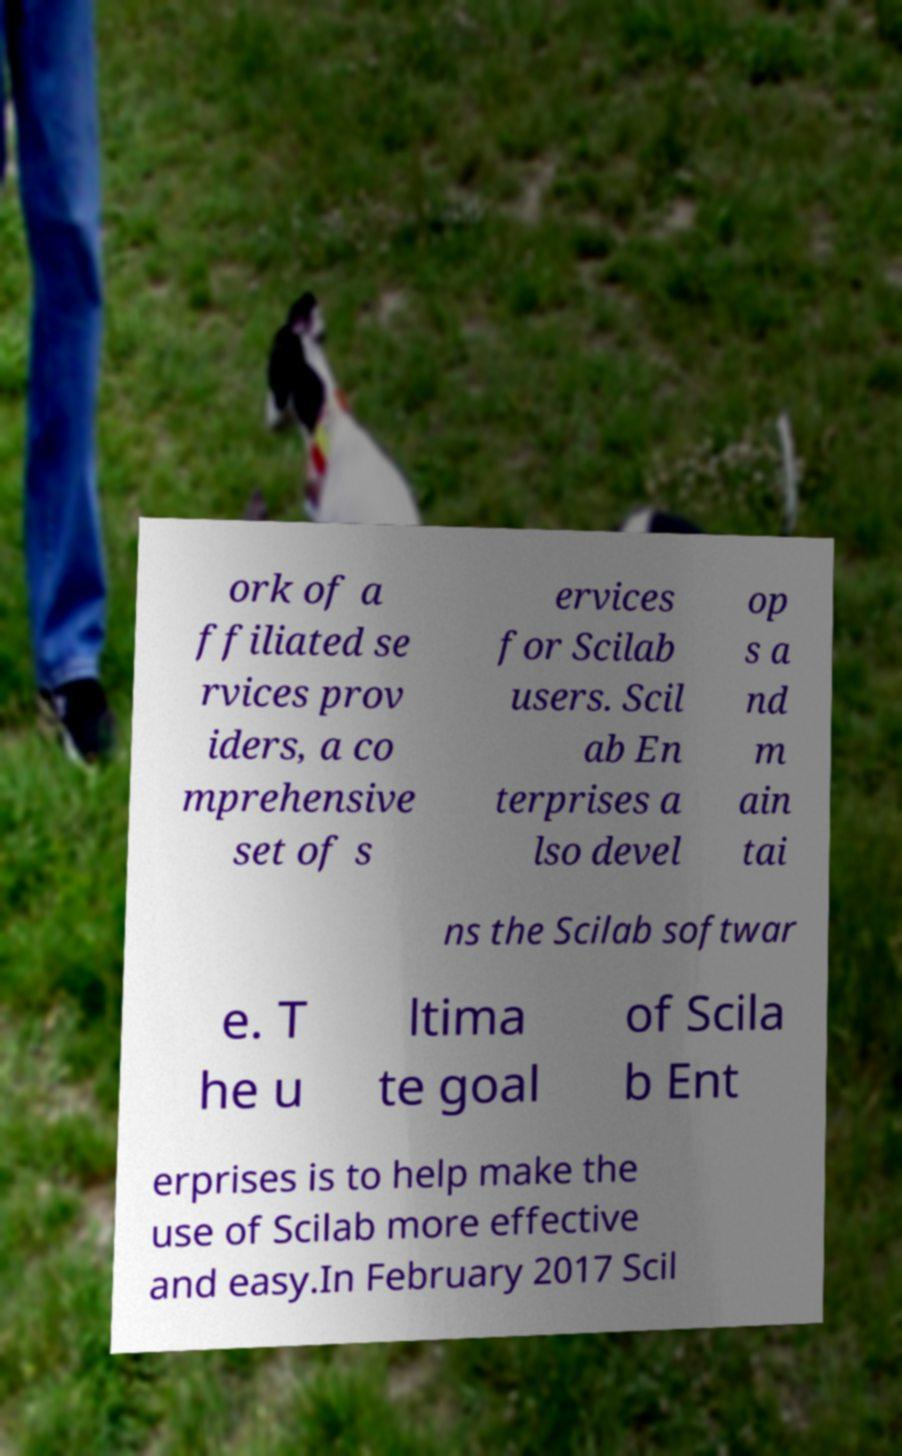Could you assist in decoding the text presented in this image and type it out clearly? ork of a ffiliated se rvices prov iders, a co mprehensive set of s ervices for Scilab users. Scil ab En terprises a lso devel op s a nd m ain tai ns the Scilab softwar e. T he u ltima te goal of Scila b Ent erprises is to help make the use of Scilab more effective and easy.In February 2017 Scil 